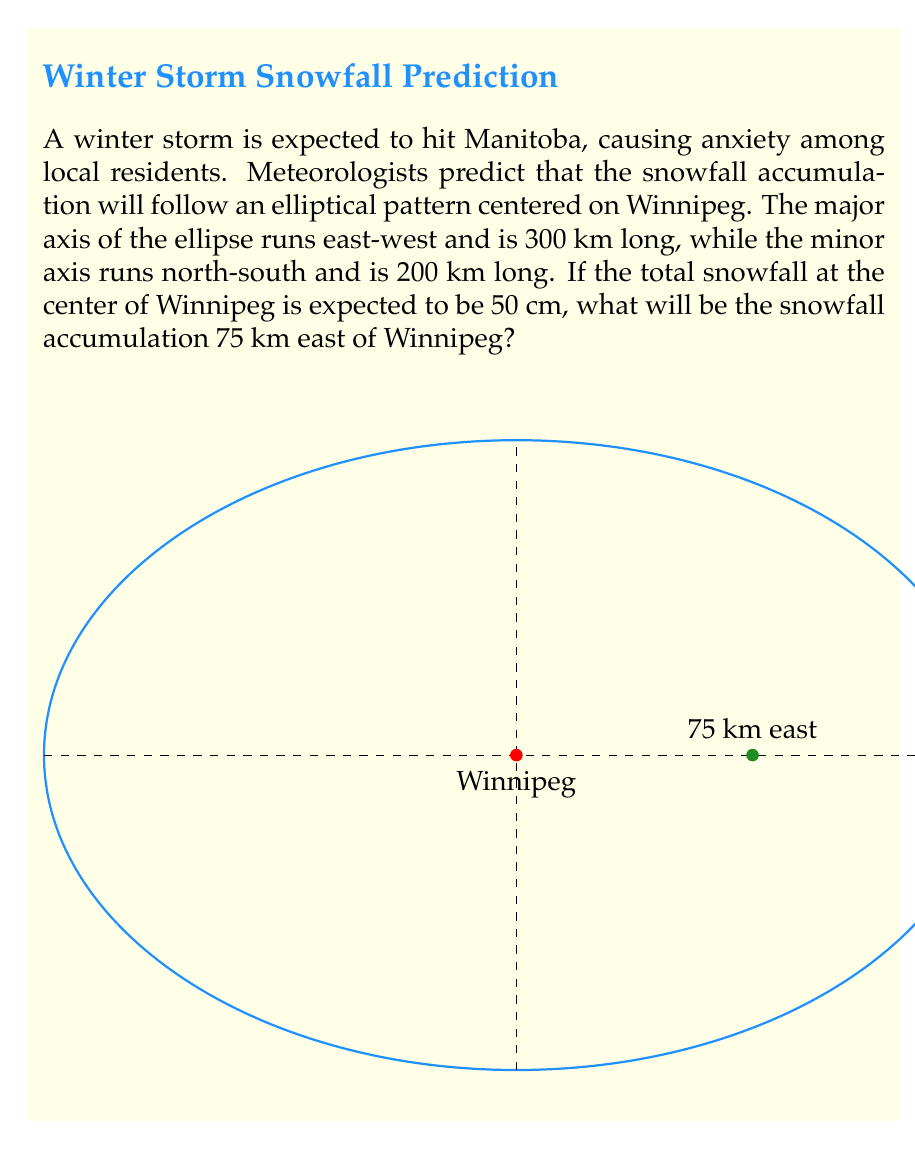Teach me how to tackle this problem. Let's approach this step-by-step:

1) The equation of an ellipse centered at the origin is:

   $$\frac{x^2}{a^2} + \frac{y^2}{b^2} = 1$$

   where $a$ is half the length of the major axis and $b$ is half the length of the minor axis.

2) In this case, $a = 150$ km and $b = 100$ km. The equation becomes:

   $$\frac{x^2}{150^2} + \frac{y^2}{100^2} = 1$$

3) We're interested in the point 75 km east of Winnipeg, so $x = 75$ and $y = 0$. Let's call the snowfall at this point $h$.

4) The snowfall follows the shape of the ellipse, so we can set up a proportion:

   $$\frac{h}{50} = \sqrt{1 - \frac{75^2}{150^2}}$$

5) Simplify the right side:

   $$\frac{h}{50} = \sqrt{1 - \frac{1}{4}} = \sqrt{\frac{3}{4}} = \frac{\sqrt{3}}{2}$$

6) Solve for $h$:

   $$h = 50 \cdot \frac{\sqrt{3}}{2} = 25\sqrt{3}$$

Therefore, the snowfall accumulation 75 km east of Winnipeg will be $25\sqrt{3}$ cm.
Answer: $25\sqrt{3}$ cm 